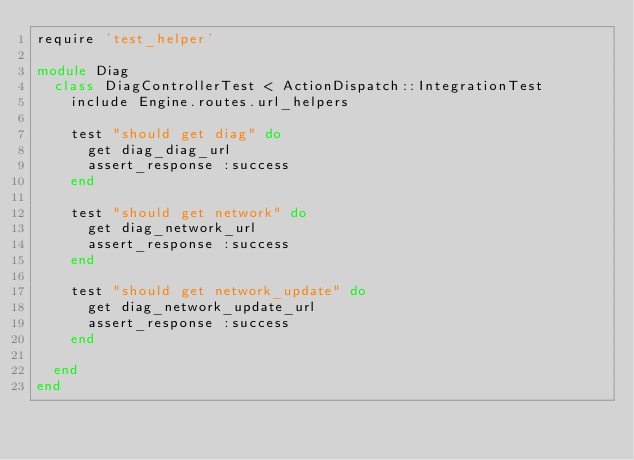<code> <loc_0><loc_0><loc_500><loc_500><_Ruby_>require 'test_helper'

module Diag
  class DiagControllerTest < ActionDispatch::IntegrationTest
    include Engine.routes.url_helpers

    test "should get diag" do
      get diag_diag_url
      assert_response :success
    end

    test "should get network" do
      get diag_network_url
      assert_response :success
    end

    test "should get network_update" do
      get diag_network_update_url
      assert_response :success
    end

  end
end
</code> 